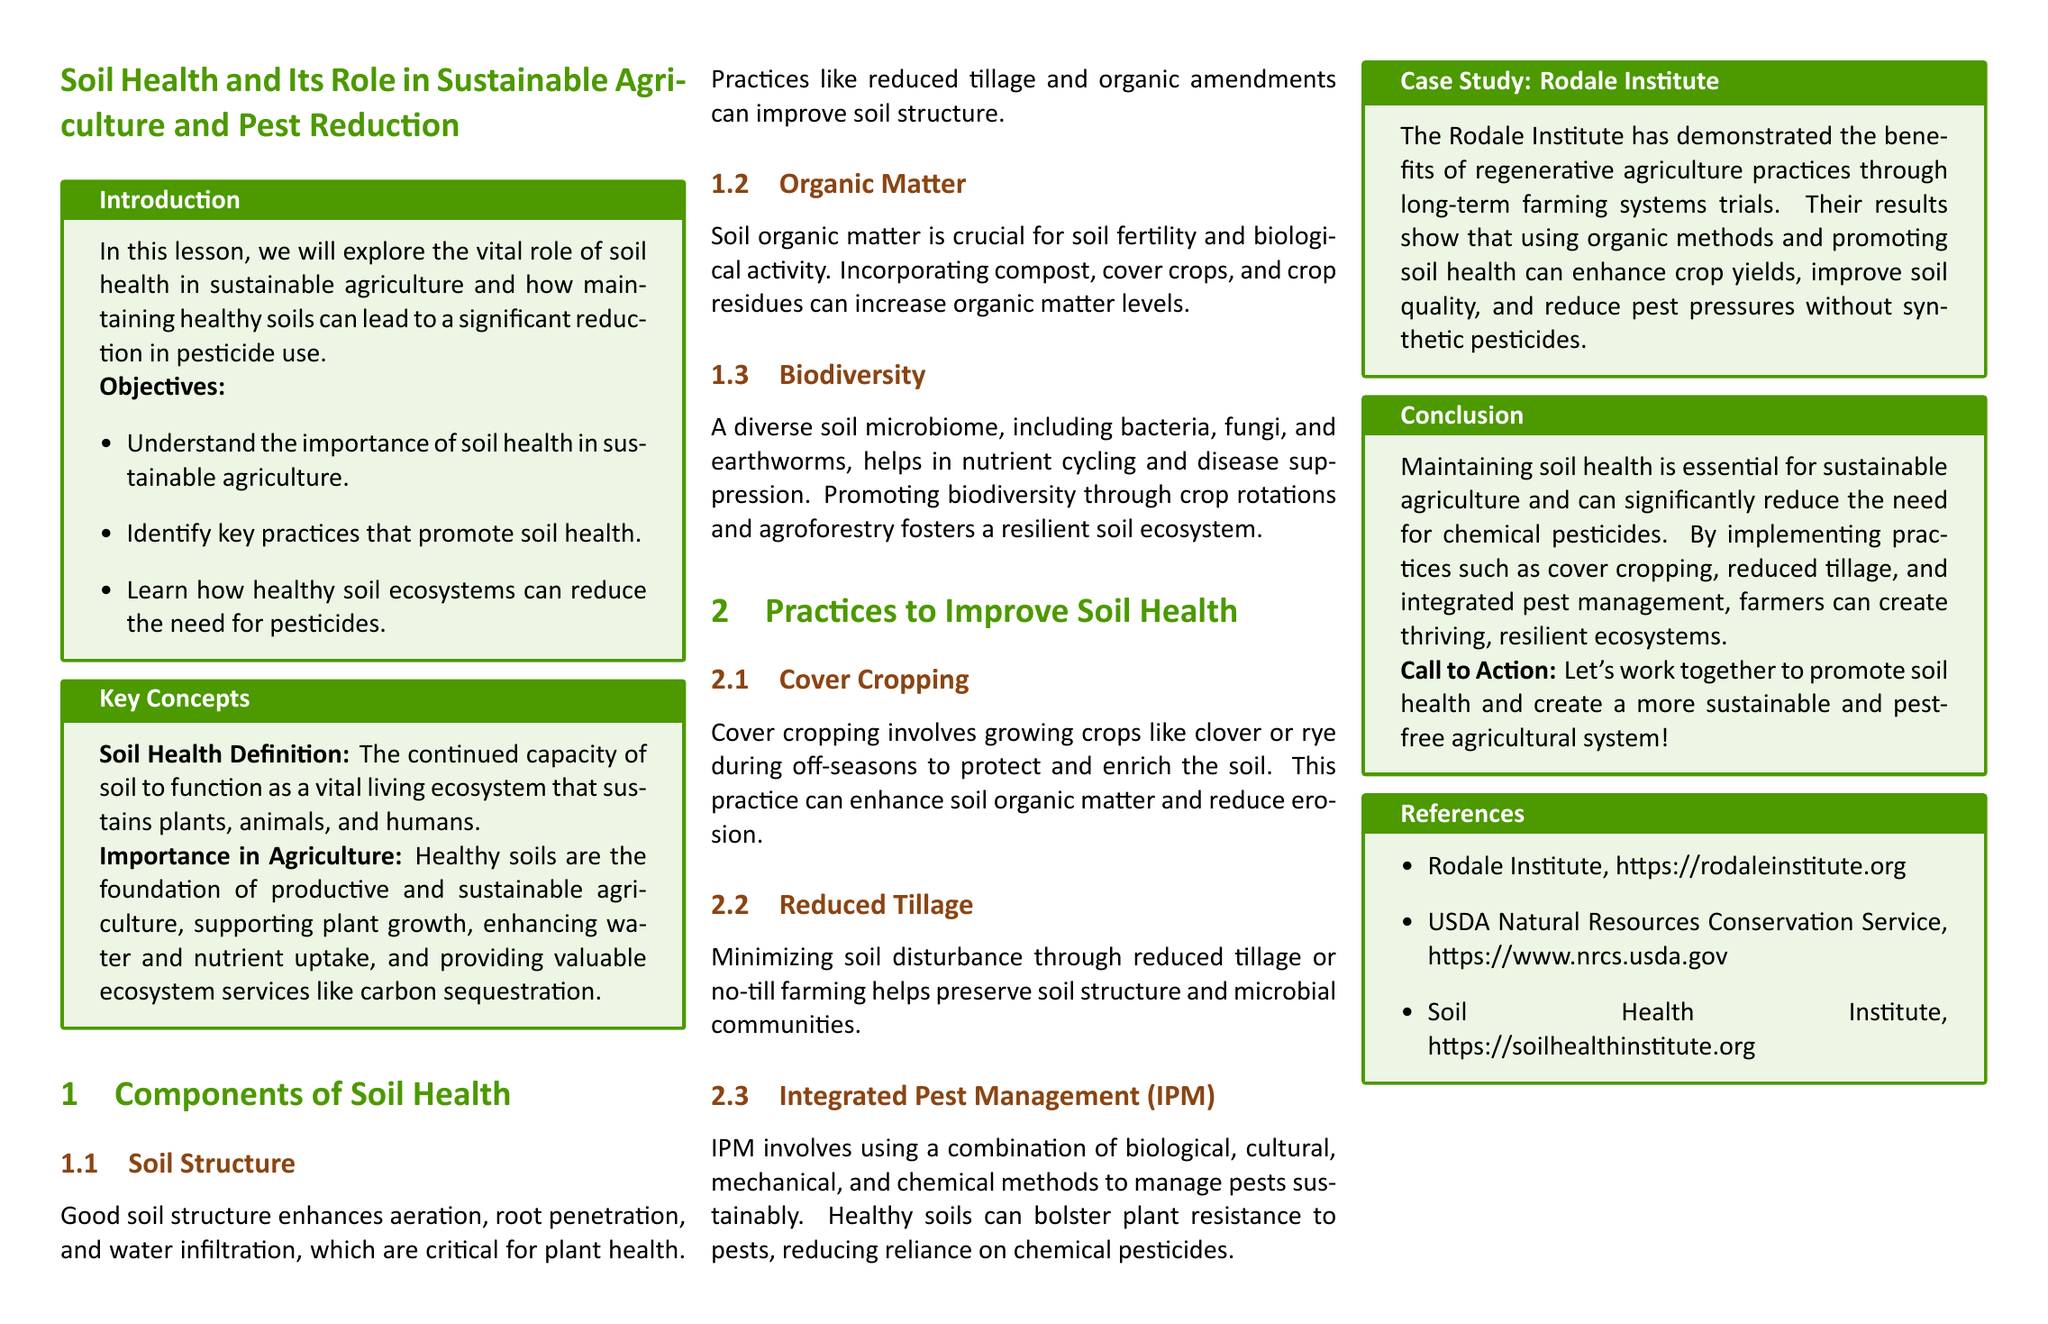what is the focus of the lesson? The lesson focuses on soil health and its role in sustainable agriculture and pest reduction.
Answer: soil health and its role in sustainable agriculture and pest reduction what is the first key practice to improve soil health mentioned? The first key practice mentioned is cover cropping.
Answer: cover cropping how does good soil structure benefit plants? Good soil structure enhances aeration, root penetration, and water infiltration, which are critical for plant health.
Answer: enhances aeration, root penetration, and water infiltration which institute is featured in the case study? The institute featured in the case study is the Rodale Institute.
Answer: Rodale Institute what are the objectives of the lesson? The objectives include understanding the importance of soil health and identifying key practices that promote soil health.
Answer: understanding the importance of soil health and identifying key practices that promote soil health what role does biodiversity play in soil health? A diverse soil microbiome helps in nutrient cycling and disease suppression.
Answer: nutrient cycling and disease suppression which method combines biological, cultural, mechanical, and chemical practices for pest management? The method is Integrated Pest Management (IPM).
Answer: Integrated Pest Management (IPM) what is called the call to action in the conclusion? The call to action is to promote soil health and create a more sustainable and pest-free agricultural system.
Answer: promote soil health and create a more sustainable and pest-free agricultural system 